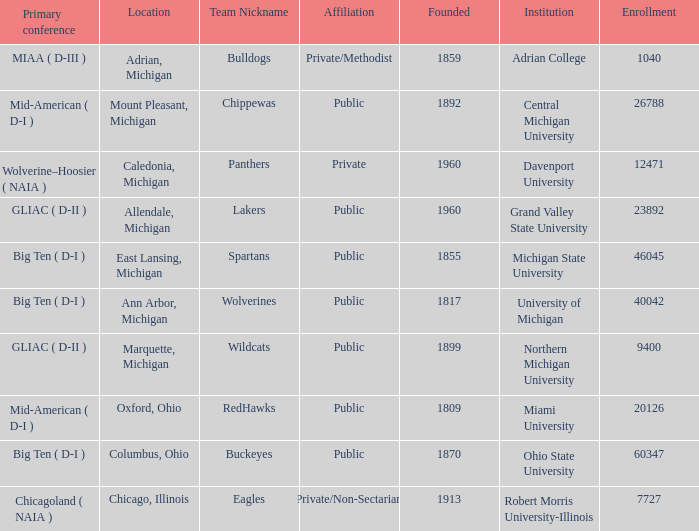How many primary conferences were held in Allendale, Michigan? 1.0. 